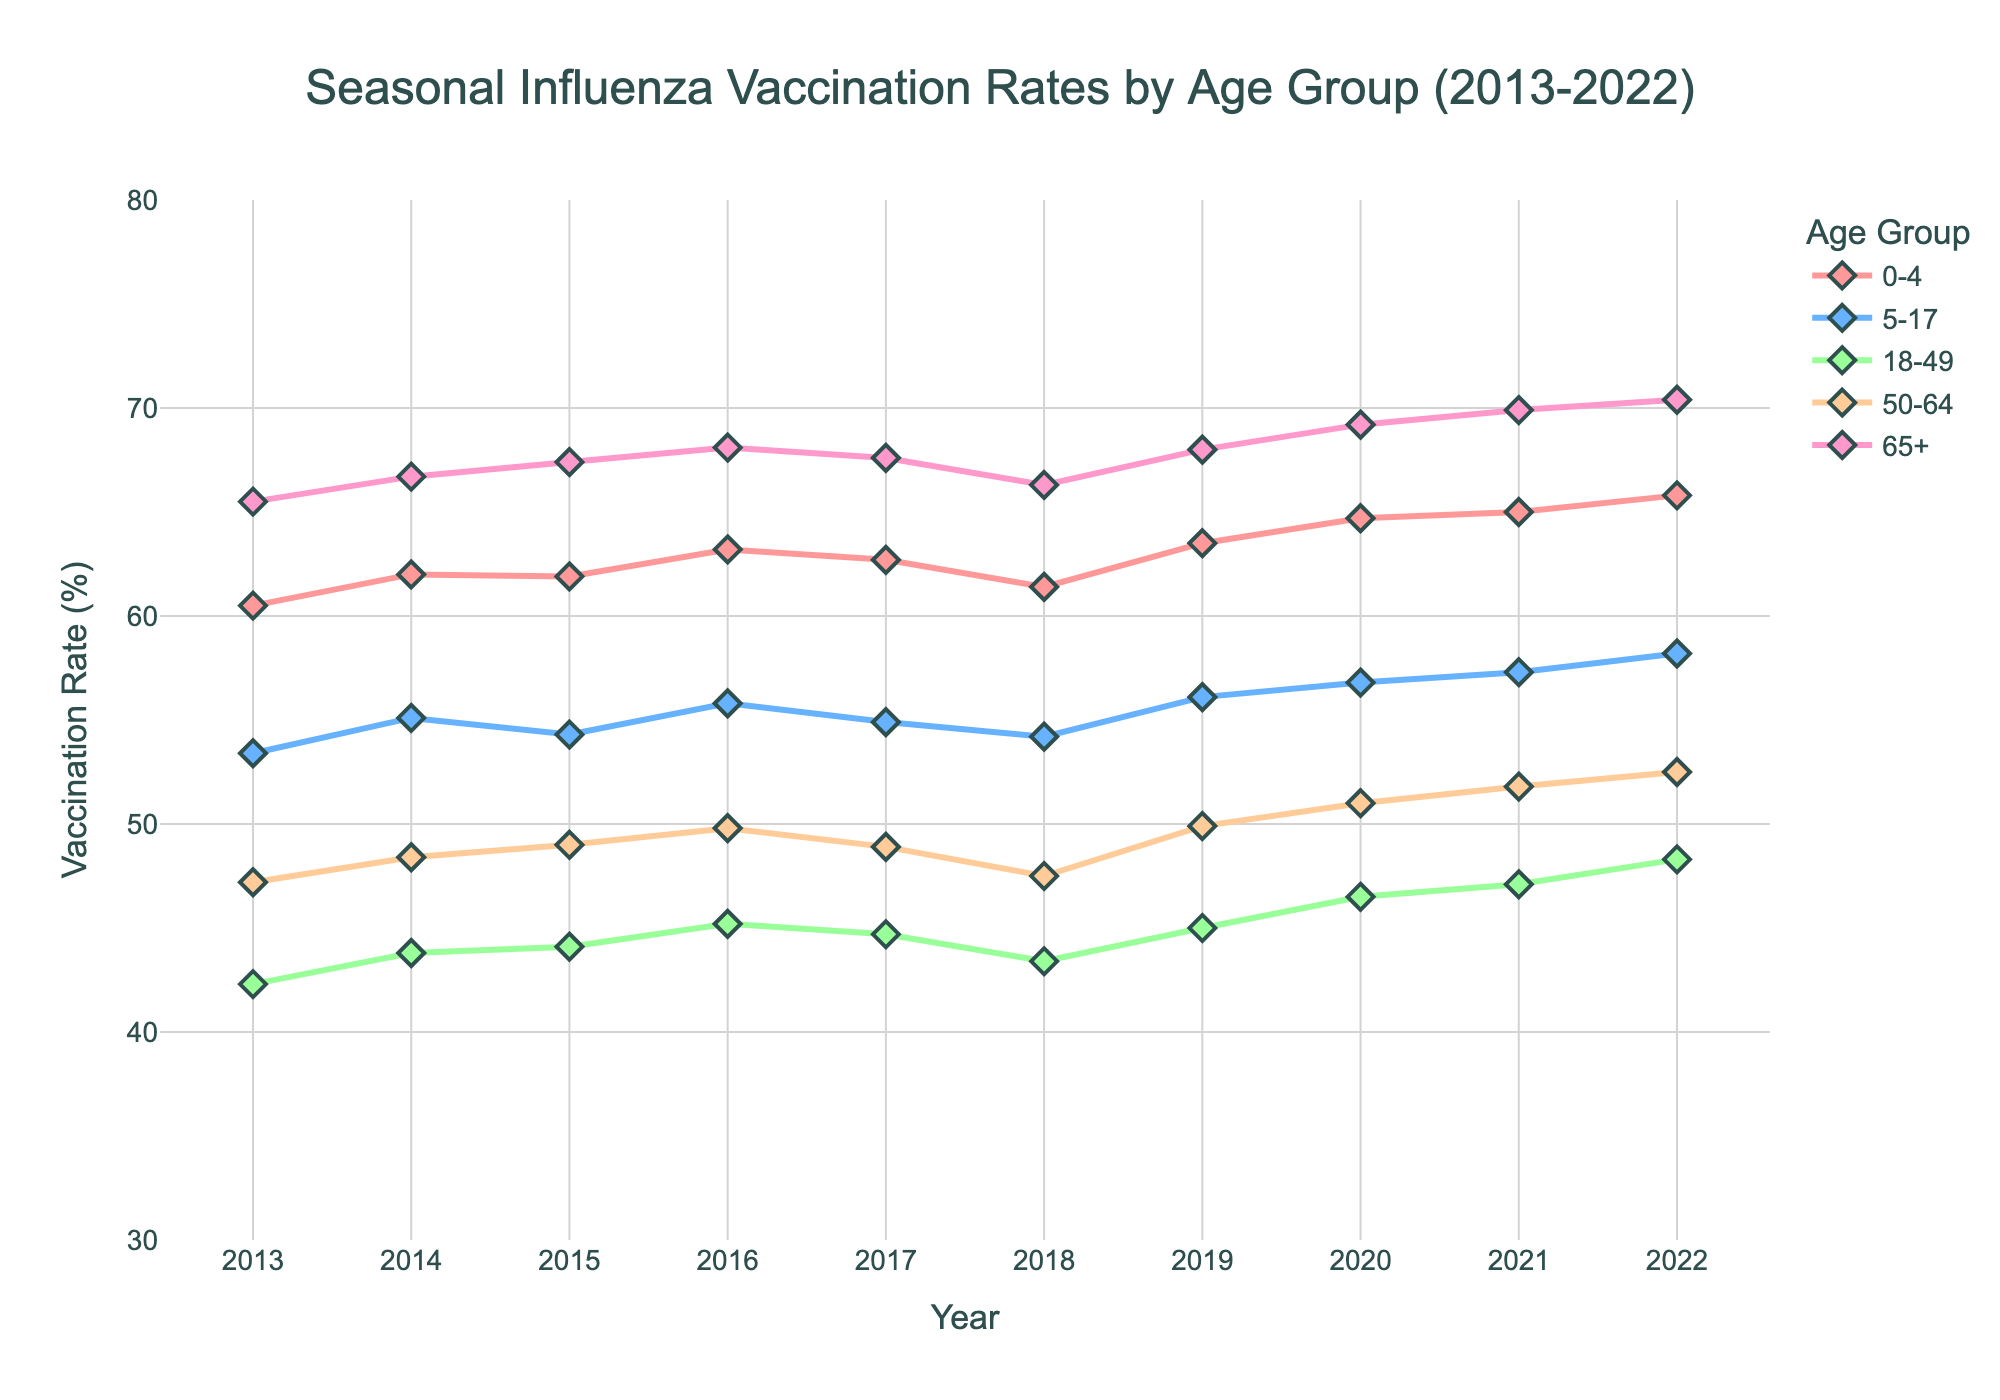What is the title of the plot? The title is displayed at the top center of the figure.
Answer: Seasonal Influenza Vaccination Rates by Age Group (2013-2022) What is the vaccination rate for the age group 65+ in 2017? Locate the data point corresponding to the year 2017 for the 65+ age group, which is marked by a specific color line and marker.
Answer: 67.6% How does the vaccination rate for children aged 0-4 in 2022 compare to 2013? Find the data points for the age group 0-4 in 2022 and 2013, then compare their values.
Answer: Higher in 2022 (65.8%) than 2013 (60.5%) Which age group had the highest vaccination rate in 2020? Look at the data points for all age groups in 2020 and identify the highest value.
Answer: 65+ What trend do you observe for the age group 18-49 over the decade? Analyze the data points connected by the line for the age group 18-49 from 2013 to 2022 and describe the general direction.
Answer: Increasing trend What is the average vaccination rate for the age group 50-64 over the 10 years? Sum the vaccination rates for the age group 50-64 from 2013 to 2022 and divide by the number of years (10).
Answer: 49.12% Which year had the lowest vaccination rate for age group 5-17? Identify the lowest data point for the age group 5-17 by visually inspecting the time series data from 2013 to 2022.
Answer: 2013 How did the vaccination rate change for the age group 0-4 from 2019 to 2020? Compare the vaccination rates for the age group 0-4 between 2019 and 2020 by calculating the difference.
Answer: Increased by 1.2% What is the range of vaccination rates for the age group 65+ over the decade? Find the minimum and maximum vaccination rates for the age group 65+ from 2013 to 2022 and calculate the range (max - min).
Answer: Range is 4.9% (70.4% - 65.5%) Which age group shows the least variation in vaccination rates over the decade? Assess the fluctuation in vaccination rates for each age group from 2013 to 2022 and determine which group has the smallest difference between the highest and lowest rates.
Answer: Age group 18-49 